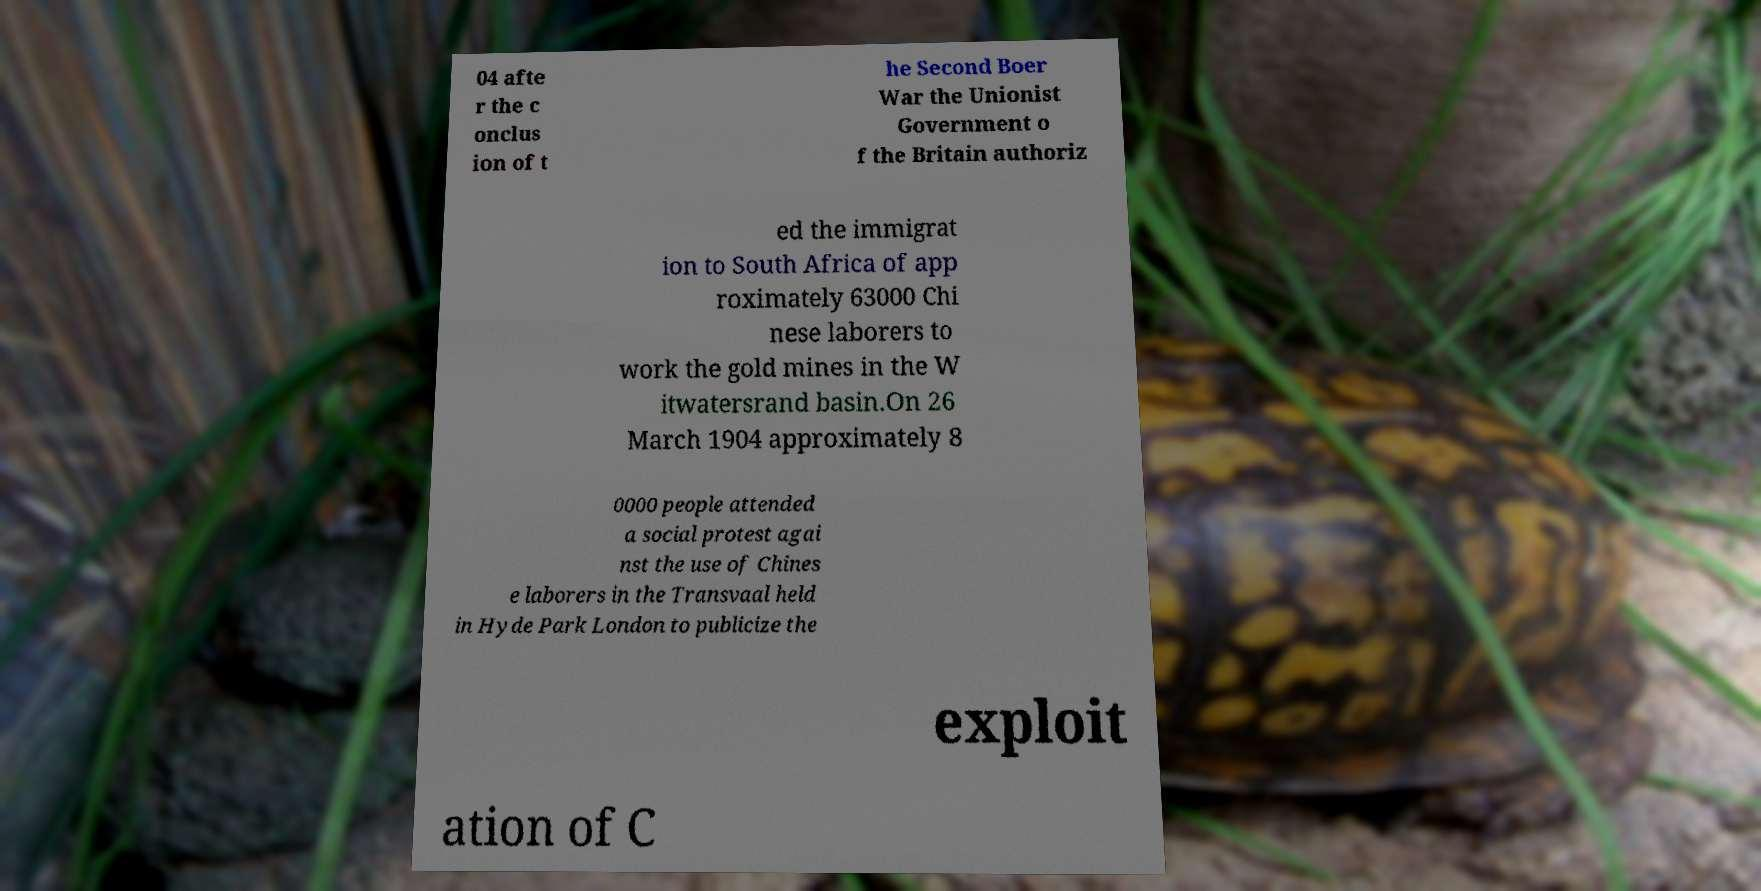I need the written content from this picture converted into text. Can you do that? 04 afte r the c onclus ion of t he Second Boer War the Unionist Government o f the Britain authoriz ed the immigrat ion to South Africa of app roximately 63000 Chi nese laborers to work the gold mines in the W itwatersrand basin.On 26 March 1904 approximately 8 0000 people attended a social protest agai nst the use of Chines e laborers in the Transvaal held in Hyde Park London to publicize the exploit ation of C 